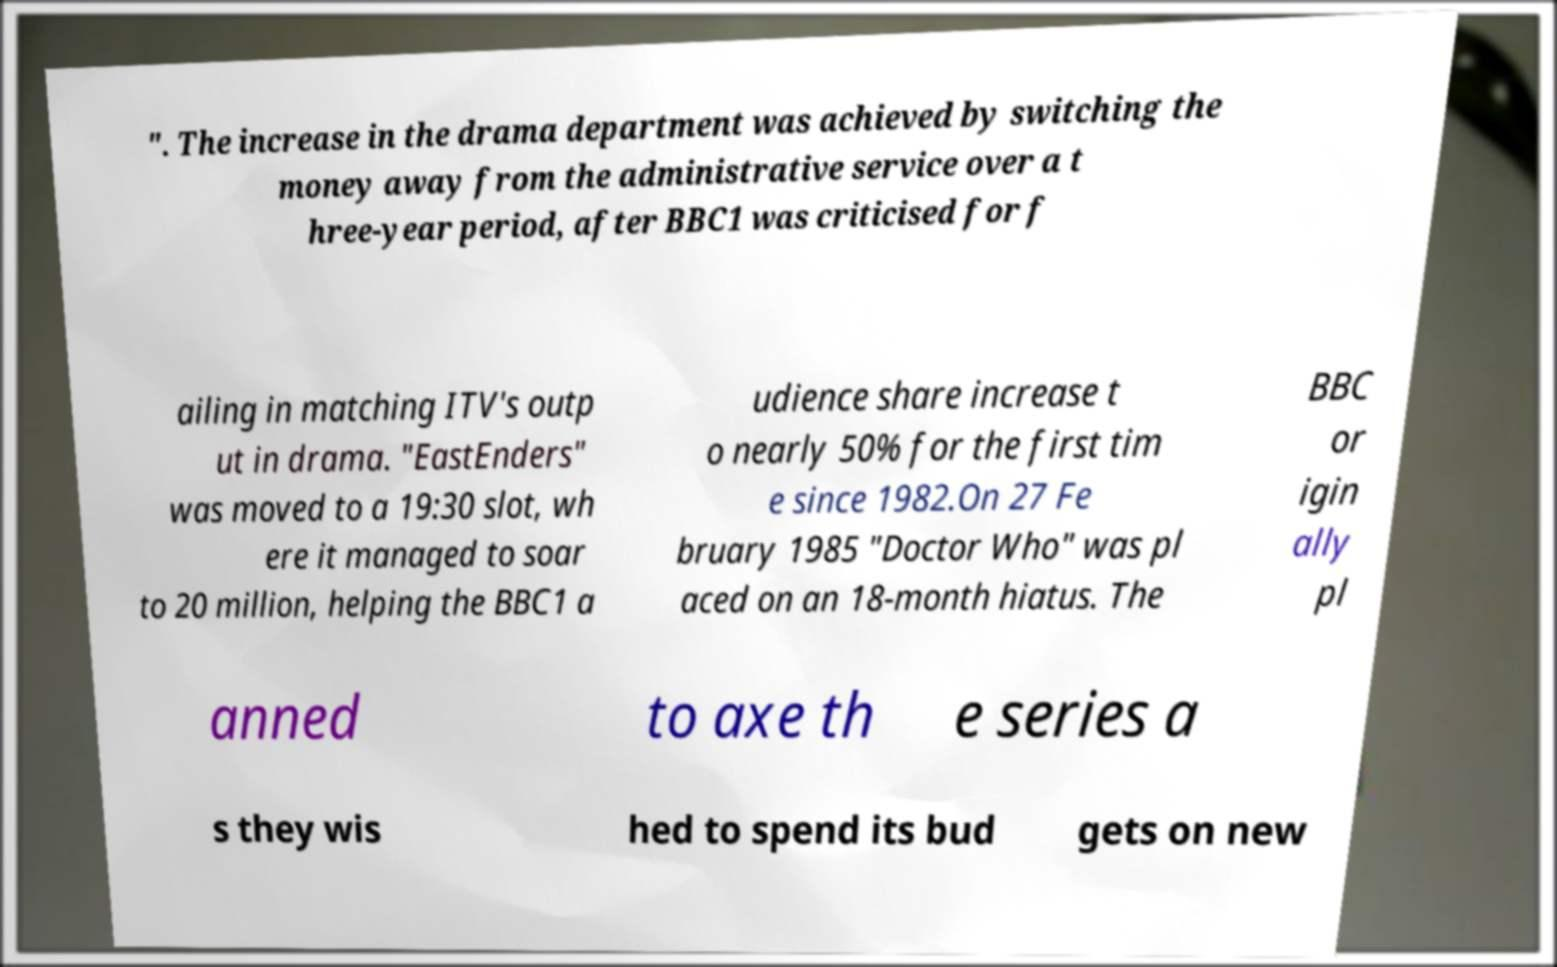Could you extract and type out the text from this image? ". The increase in the drama department was achieved by switching the money away from the administrative service over a t hree-year period, after BBC1 was criticised for f ailing in matching ITV's outp ut in drama. "EastEnders" was moved to a 19:30 slot, wh ere it managed to soar to 20 million, helping the BBC1 a udience share increase t o nearly 50% for the first tim e since 1982.On 27 Fe bruary 1985 "Doctor Who" was pl aced on an 18-month hiatus. The BBC or igin ally pl anned to axe th e series a s they wis hed to spend its bud gets on new 